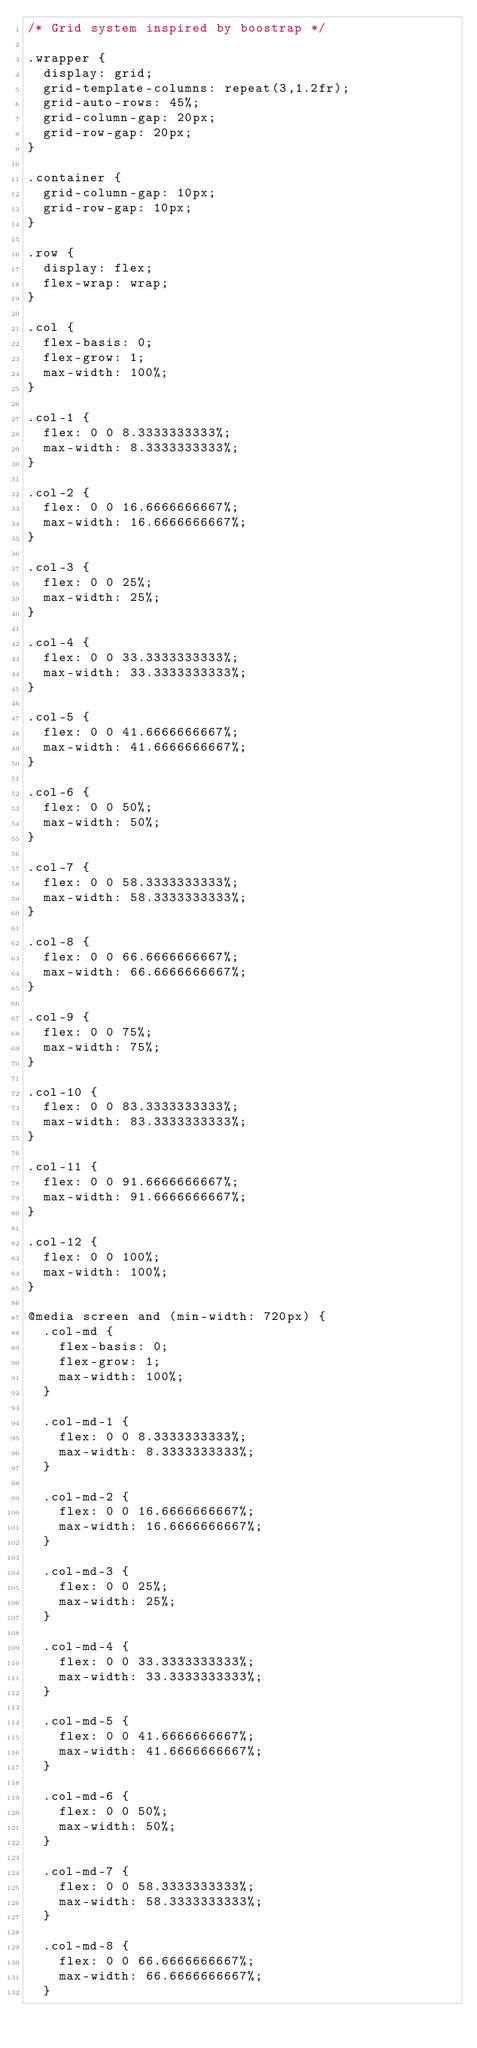<code> <loc_0><loc_0><loc_500><loc_500><_CSS_>/* Grid system inspired by boostrap */

.wrapper {
  display: grid;
  grid-template-columns: repeat(3,1.2fr);
  grid-auto-rows: 45%;
  grid-column-gap: 20px;
  grid-row-gap: 20px;
}

.container {
  grid-column-gap: 10px;
  grid-row-gap: 10px;
}

.row {
  display: flex;
  flex-wrap: wrap;
}

.col {
  flex-basis: 0;
  flex-grow: 1;
  max-width: 100%;
}

.col-1 {
  flex: 0 0 8.3333333333%;
  max-width: 8.3333333333%;
}

.col-2 {
  flex: 0 0 16.6666666667%;
  max-width: 16.6666666667%;
}

.col-3 {
  flex: 0 0 25%;
  max-width: 25%;
}

.col-4 {
  flex: 0 0 33.3333333333%;
  max-width: 33.3333333333%;
}

.col-5 {
  flex: 0 0 41.6666666667%;
  max-width: 41.6666666667%;
}

.col-6 {
  flex: 0 0 50%;
  max-width: 50%;
}

.col-7 {
  flex: 0 0 58.3333333333%;
  max-width: 58.3333333333%;
}

.col-8 {
  flex: 0 0 66.6666666667%;
  max-width: 66.6666666667%;
}

.col-9 {
  flex: 0 0 75%;
  max-width: 75%;
}

.col-10 {
  flex: 0 0 83.3333333333%;
  max-width: 83.3333333333%;
}

.col-11 {
  flex: 0 0 91.6666666667%;
  max-width: 91.6666666667%;
}

.col-12 {
  flex: 0 0 100%;
  max-width: 100%;
}

@media screen and (min-width: 720px) {
  .col-md {
    flex-basis: 0;
    flex-grow: 1;
    max-width: 100%;
  }

  .col-md-1 {
    flex: 0 0 8.3333333333%;
    max-width: 8.3333333333%;
  }

  .col-md-2 {
    flex: 0 0 16.6666666667%;
    max-width: 16.6666666667%;
  }

  .col-md-3 {
    flex: 0 0 25%;
    max-width: 25%;
  }

  .col-md-4 {
    flex: 0 0 33.3333333333%;
    max-width: 33.3333333333%;
  }

  .col-md-5 {
    flex: 0 0 41.6666666667%;
    max-width: 41.6666666667%;
  }

  .col-md-6 {
    flex: 0 0 50%;
    max-width: 50%;
  }

  .col-md-7 {
    flex: 0 0 58.3333333333%;
    max-width: 58.3333333333%;
  }

  .col-md-8 {
    flex: 0 0 66.6666666667%;
    max-width: 66.6666666667%;
  }
</code> 